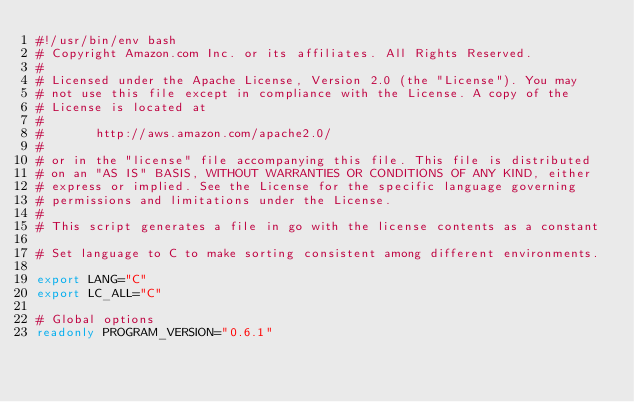Convert code to text. <code><loc_0><loc_0><loc_500><loc_500><_Bash_>#!/usr/bin/env bash
# Copyright Amazon.com Inc. or its affiliates. All Rights Reserved.
#
# Licensed under the Apache License, Version 2.0 (the "License"). You may
# not use this file except in compliance with the License. A copy of the
# License is located at
#
#       http://aws.amazon.com/apache2.0/
#
# or in the "license" file accompanying this file. This file is distributed
# on an "AS IS" BASIS, WITHOUT WARRANTIES OR CONDITIONS OF ANY KIND, either
# express or implied. See the License for the specific language governing
# permissions and limitations under the License.
#
# This script generates a file in go with the license contents as a constant

# Set language to C to make sorting consistent among different environments.

export LANG="C"
export LC_ALL="C"

# Global options
readonly PROGRAM_VERSION="0.6.1"</code> 